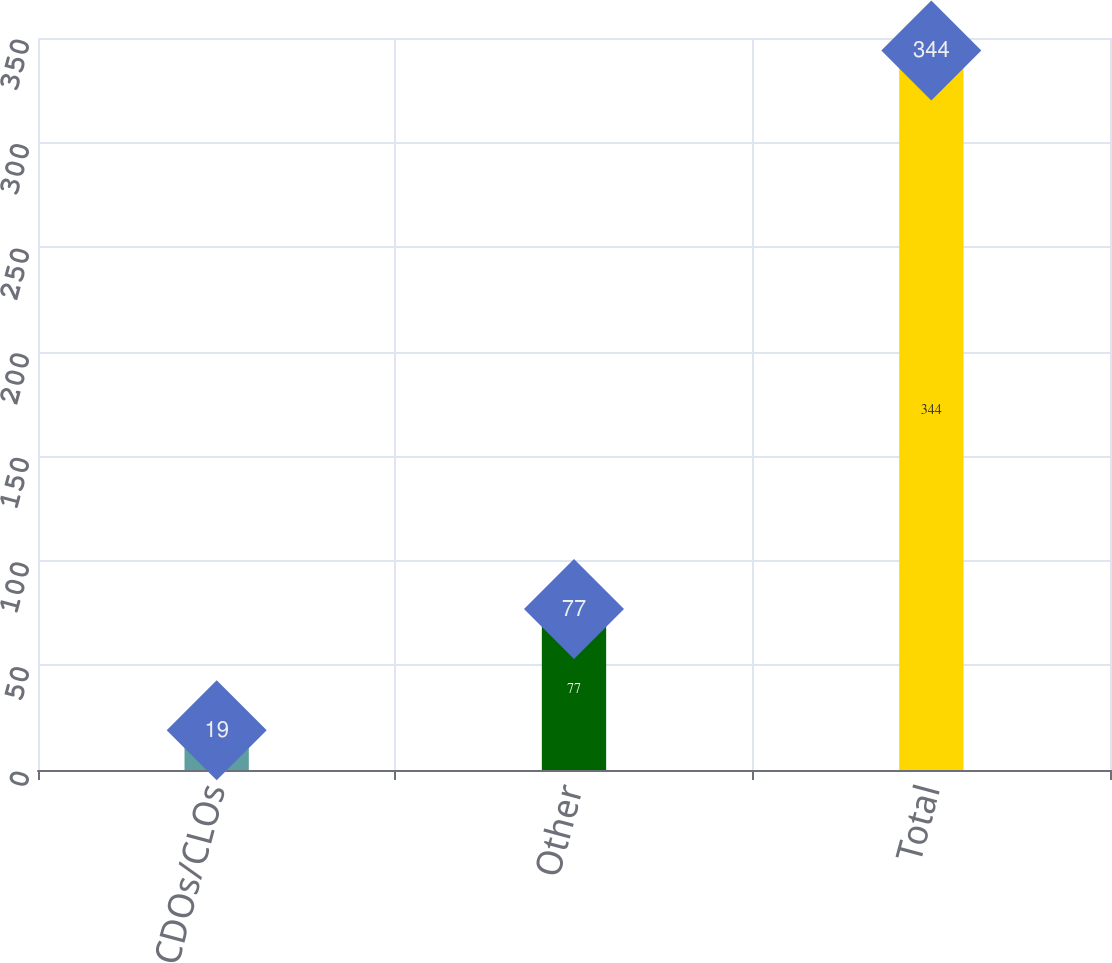<chart> <loc_0><loc_0><loc_500><loc_500><bar_chart><fcel>CDOs/CLOs<fcel>Other<fcel>Total<nl><fcel>19<fcel>77<fcel>344<nl></chart> 